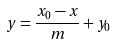<formula> <loc_0><loc_0><loc_500><loc_500>y = \frac { x _ { 0 } - x } { m } + y _ { 0 }</formula> 